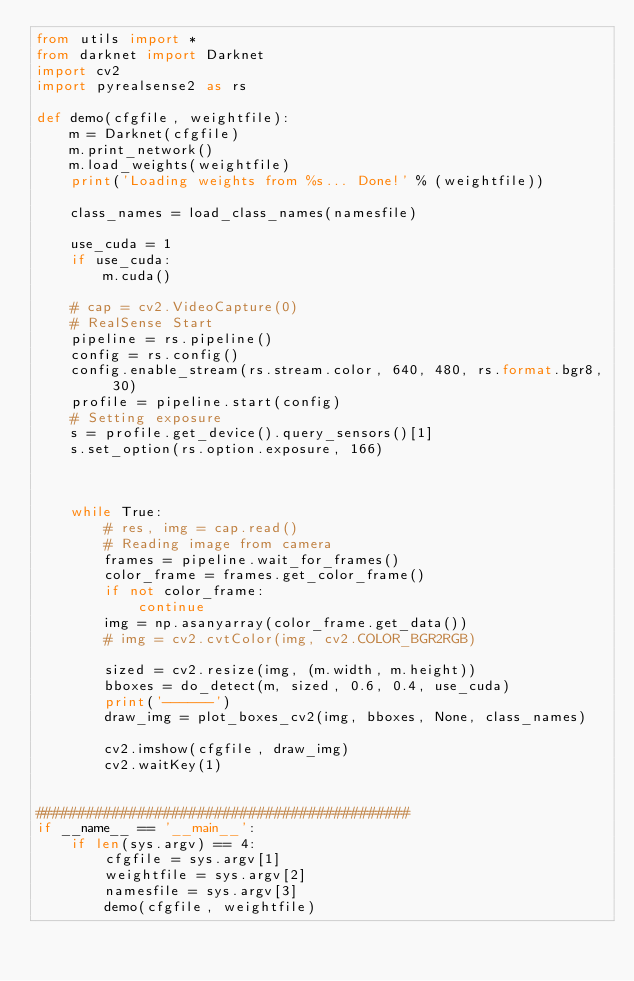<code> <loc_0><loc_0><loc_500><loc_500><_Python_>from utils import *
from darknet import Darknet
import cv2
import pyrealsense2 as rs

def demo(cfgfile, weightfile):
    m = Darknet(cfgfile)
    m.print_network()
    m.load_weights(weightfile)
    print('Loading weights from %s... Done!' % (weightfile))

    class_names = load_class_names(namesfile)

    use_cuda = 1
    if use_cuda:
        m.cuda()

    # cap = cv2.VideoCapture(0)
    # RealSense Start
    pipeline = rs.pipeline()
    config = rs.config()
    config.enable_stream(rs.stream.color, 640, 480, rs.format.bgr8, 30)
    profile = pipeline.start(config)
    # Setting exposure
    s = profile.get_device().query_sensors()[1]
    s.set_option(rs.option.exposure, 166)



    while True:
        # res, img = cap.read()
        # Reading image from camera
        frames = pipeline.wait_for_frames()
        color_frame = frames.get_color_frame()
        if not color_frame:
            continue
        img = np.asanyarray(color_frame.get_data())
        # img = cv2.cvtColor(img, cv2.COLOR_BGR2RGB)

        sized = cv2.resize(img, (m.width, m.height))
        bboxes = do_detect(m, sized, 0.6, 0.4, use_cuda)
        print('------')
        draw_img = plot_boxes_cv2(img, bboxes, None, class_names)

        cv2.imshow(cfgfile, draw_img)
        cv2.waitKey(1)


############################################
if __name__ == '__main__':
    if len(sys.argv) == 4:
        cfgfile = sys.argv[1]
        weightfile = sys.argv[2]
        namesfile = sys.argv[3]
        demo(cfgfile, weightfile)</code> 